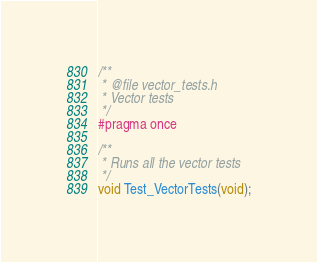<code> <loc_0><loc_0><loc_500><loc_500><_C_>/**
 * @file vector_tests.h
 * Vector tests
 */
#pragma once

/**
 * Runs all the vector tests
 */
void Test_VectorTests(void);
</code> 